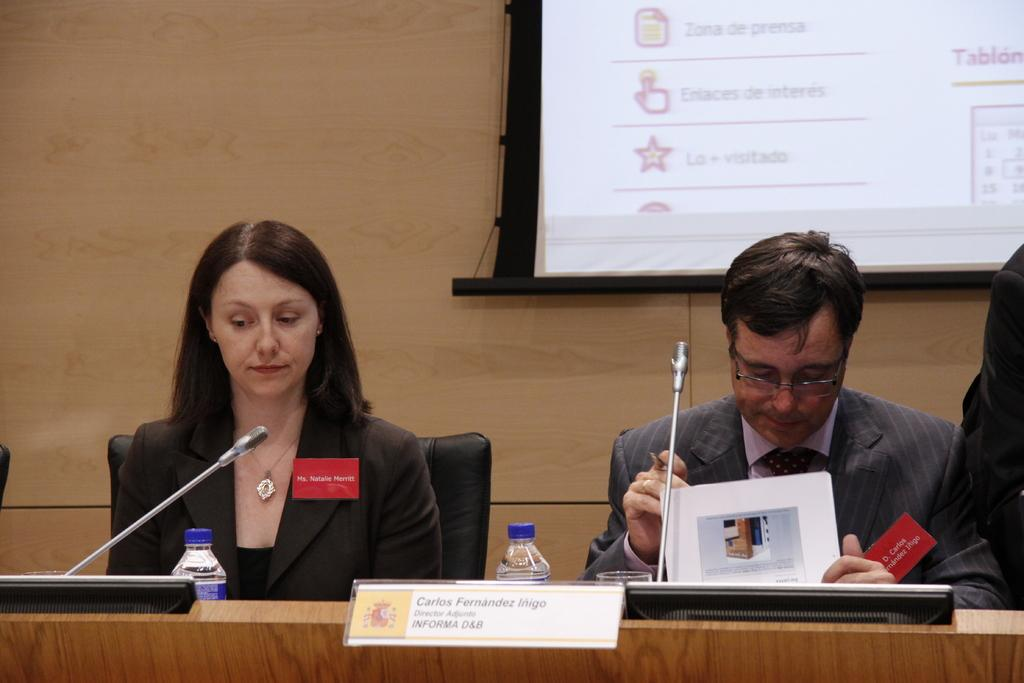Who is present in the image? There is a woman and a man in the image. What are they doing in the image? Both the woman and the man are sitting on chairs. What is in front of them? There is a table in front of them. What can be seen on the table? There are bottles on the table. What is visible in the background? There is a wall with a screen in the background. How many sheep are in the flock that is visible in the image? There is no flock of sheep present in the image. What type of power source is used to operate the screen in the background? The image does not provide information about the power source for the screen in the background. 